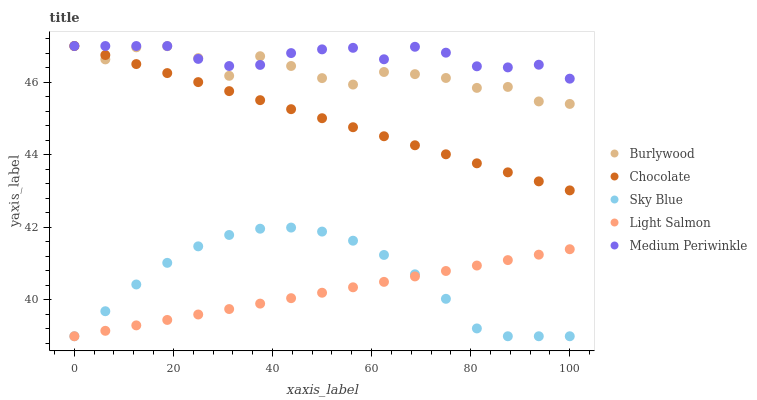Does Light Salmon have the minimum area under the curve?
Answer yes or no. Yes. Does Medium Periwinkle have the maximum area under the curve?
Answer yes or no. Yes. Does Sky Blue have the minimum area under the curve?
Answer yes or no. No. Does Sky Blue have the maximum area under the curve?
Answer yes or no. No. Is Light Salmon the smoothest?
Answer yes or no. Yes. Is Burlywood the roughest?
Answer yes or no. Yes. Is Sky Blue the smoothest?
Answer yes or no. No. Is Sky Blue the roughest?
Answer yes or no. No. Does Sky Blue have the lowest value?
Answer yes or no. Yes. Does Medium Periwinkle have the lowest value?
Answer yes or no. No. Does Chocolate have the highest value?
Answer yes or no. Yes. Does Sky Blue have the highest value?
Answer yes or no. No. Is Light Salmon less than Medium Periwinkle?
Answer yes or no. Yes. Is Medium Periwinkle greater than Sky Blue?
Answer yes or no. Yes. Does Chocolate intersect Burlywood?
Answer yes or no. Yes. Is Chocolate less than Burlywood?
Answer yes or no. No. Is Chocolate greater than Burlywood?
Answer yes or no. No. Does Light Salmon intersect Medium Periwinkle?
Answer yes or no. No. 